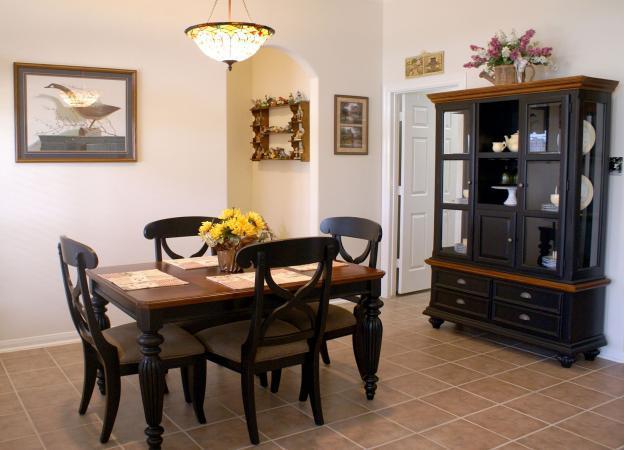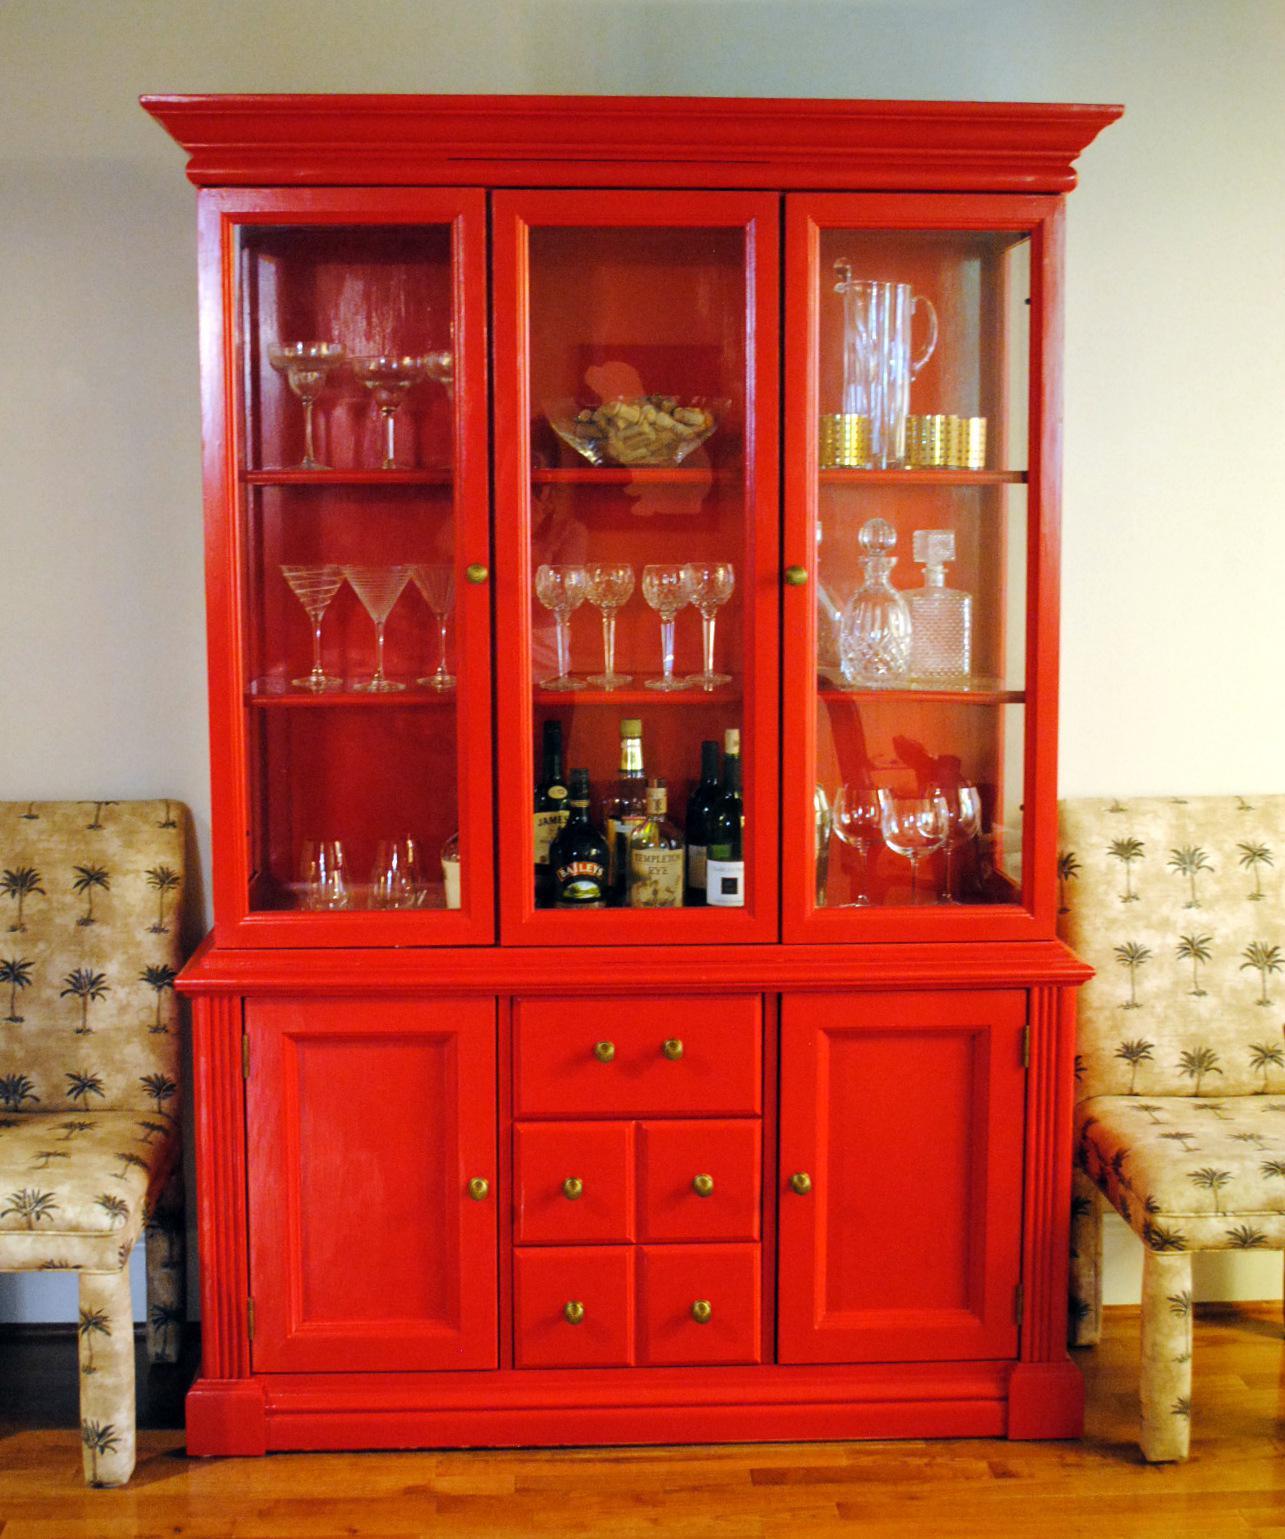The first image is the image on the left, the second image is the image on the right. Evaluate the accuracy of this statement regarding the images: "A wooden hutch with three glass doors in its upper section has a center section of drawers between two solid doors in the bottom section.". Is it true? Answer yes or no. Yes. The first image is the image on the left, the second image is the image on the right. Evaluate the accuracy of this statement regarding the images: "One white hutch has a straight top and three shelves in the upper section, and a gray hutch has an upper center glass door that is wider than the two side glass sections.". Is it true? Answer yes or no. No. The first image is the image on the left, the second image is the image on the right. Considering the images on both sides, is "The cabinet in the image on the right is charcoal grey, while the one on the left is white." valid? Answer yes or no. No. The first image is the image on the left, the second image is the image on the right. Given the left and right images, does the statement "The cabinet on the left is rich brown wood, and the cabinet on the right is white, with scrollwork and legs on the base." hold true? Answer yes or no. No. 